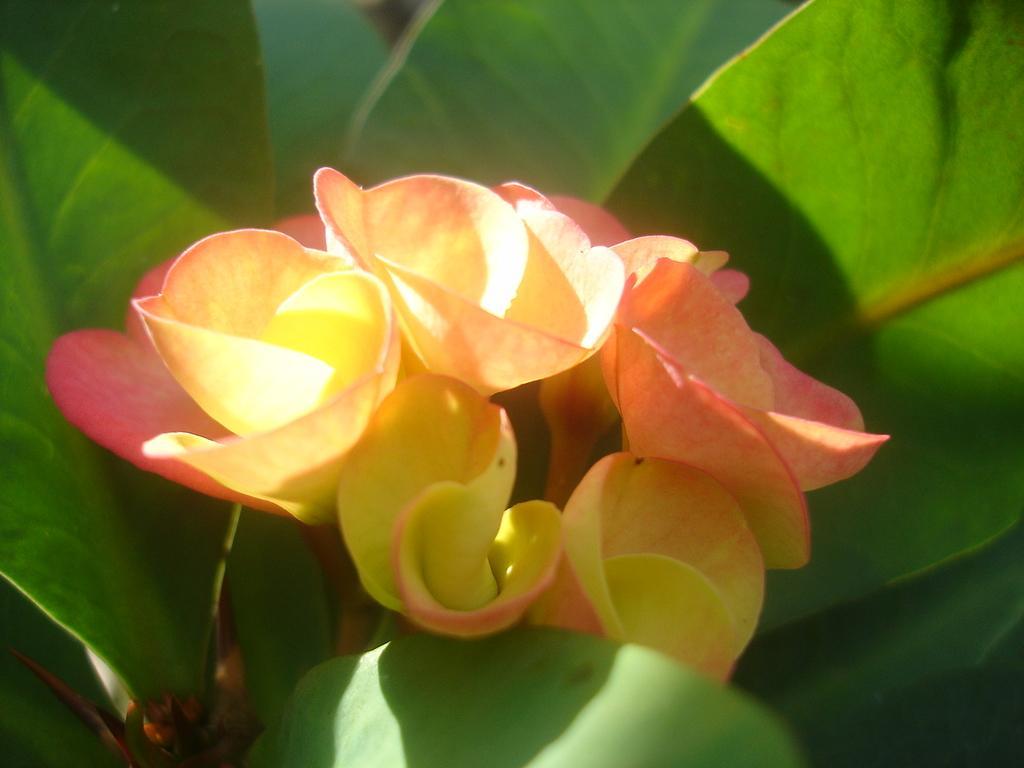Can you describe this image briefly? In this picture I can see some flower to the plants. 